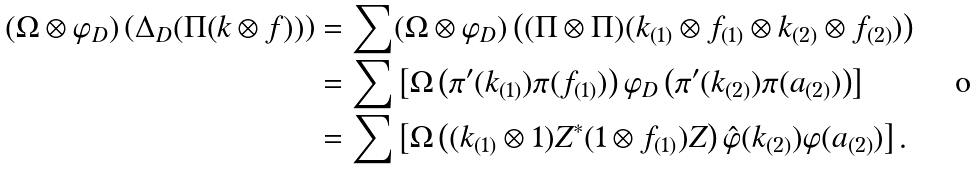<formula> <loc_0><loc_0><loc_500><loc_500>( \Omega \otimes \varphi _ { D } ) \left ( \Delta _ { D } ( \Pi ( k \otimes f ) ) \right ) & = \sum ( \Omega \otimes \varphi _ { D } ) \left ( ( \Pi \otimes \Pi ) ( k _ { ( 1 ) } \otimes f _ { ( 1 ) } \otimes k _ { ( 2 ) } \otimes f _ { ( 2 ) } ) \right ) \\ & = \sum \left [ \Omega \left ( \pi ^ { \prime } ( k _ { ( 1 ) } ) \pi ( f _ { ( 1 ) } ) \right ) \varphi _ { D } \left ( \pi ^ { \prime } ( k _ { ( 2 ) } ) \pi ( a _ { ( 2 ) } ) \right ) \right ] \\ & = \sum \left [ \Omega \left ( ( k _ { ( 1 ) } \otimes 1 ) Z ^ { * } ( 1 \otimes f _ { ( 1 ) } ) Z \right ) \hat { \varphi } ( k _ { ( 2 ) } ) \varphi ( a _ { ( 2 ) } ) \right ] .</formula> 